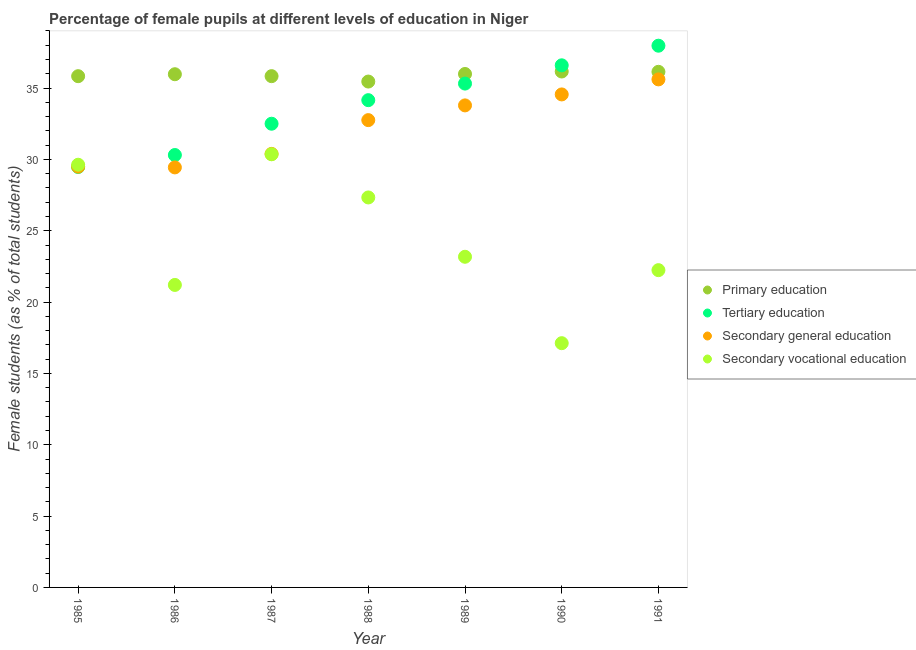What is the percentage of female students in primary education in 1989?
Your answer should be compact. 35.99. Across all years, what is the maximum percentage of female students in primary education?
Make the answer very short. 36.16. Across all years, what is the minimum percentage of female students in primary education?
Your answer should be very brief. 35.46. In which year was the percentage of female students in secondary vocational education maximum?
Provide a short and direct response. 1987. In which year was the percentage of female students in secondary education minimum?
Keep it short and to the point. 1986. What is the total percentage of female students in primary education in the graph?
Offer a very short reply. 251.38. What is the difference between the percentage of female students in tertiary education in 1985 and that in 1991?
Your response must be concise. -8.5. What is the difference between the percentage of female students in primary education in 1989 and the percentage of female students in secondary vocational education in 1988?
Offer a terse response. 8.65. What is the average percentage of female students in primary education per year?
Provide a succinct answer. 35.91. In the year 1989, what is the difference between the percentage of female students in secondary education and percentage of female students in primary education?
Offer a very short reply. -2.2. What is the ratio of the percentage of female students in secondary vocational education in 1986 to that in 1990?
Your response must be concise. 1.24. Is the percentage of female students in secondary vocational education in 1986 less than that in 1987?
Your answer should be very brief. Yes. What is the difference between the highest and the second highest percentage of female students in secondary vocational education?
Give a very brief answer. 0.73. What is the difference between the highest and the lowest percentage of female students in secondary vocational education?
Offer a terse response. 13.24. Does the percentage of female students in primary education monotonically increase over the years?
Your answer should be very brief. No. Is the percentage of female students in tertiary education strictly greater than the percentage of female students in secondary vocational education over the years?
Offer a terse response. No. How many dotlines are there?
Your answer should be compact. 4. How many years are there in the graph?
Offer a very short reply. 7. Does the graph contain any zero values?
Ensure brevity in your answer.  No. How are the legend labels stacked?
Give a very brief answer. Vertical. What is the title of the graph?
Your answer should be very brief. Percentage of female pupils at different levels of education in Niger. What is the label or title of the Y-axis?
Keep it short and to the point. Female students (as % of total students). What is the Female students (as % of total students) of Primary education in 1985?
Provide a succinct answer. 35.83. What is the Female students (as % of total students) in Tertiary education in 1985?
Offer a very short reply. 29.47. What is the Female students (as % of total students) of Secondary general education in 1985?
Ensure brevity in your answer.  29.49. What is the Female students (as % of total students) of Secondary vocational education in 1985?
Provide a succinct answer. 29.63. What is the Female students (as % of total students) in Primary education in 1986?
Offer a terse response. 35.97. What is the Female students (as % of total students) in Tertiary education in 1986?
Your answer should be very brief. 30.31. What is the Female students (as % of total students) of Secondary general education in 1986?
Offer a very short reply. 29.44. What is the Female students (as % of total students) in Secondary vocational education in 1986?
Give a very brief answer. 21.2. What is the Female students (as % of total students) of Primary education in 1987?
Your answer should be very brief. 35.83. What is the Female students (as % of total students) in Tertiary education in 1987?
Your answer should be compact. 32.5. What is the Female students (as % of total students) in Secondary general education in 1987?
Provide a short and direct response. 30.39. What is the Female students (as % of total students) of Secondary vocational education in 1987?
Offer a terse response. 30.36. What is the Female students (as % of total students) of Primary education in 1988?
Keep it short and to the point. 35.46. What is the Female students (as % of total students) of Tertiary education in 1988?
Make the answer very short. 34.15. What is the Female students (as % of total students) of Secondary general education in 1988?
Provide a short and direct response. 32.75. What is the Female students (as % of total students) in Secondary vocational education in 1988?
Make the answer very short. 27.33. What is the Female students (as % of total students) of Primary education in 1989?
Your answer should be compact. 35.99. What is the Female students (as % of total students) in Tertiary education in 1989?
Provide a short and direct response. 35.31. What is the Female students (as % of total students) of Secondary general education in 1989?
Offer a very short reply. 33.79. What is the Female students (as % of total students) of Secondary vocational education in 1989?
Offer a terse response. 23.18. What is the Female students (as % of total students) in Primary education in 1990?
Keep it short and to the point. 36.16. What is the Female students (as % of total students) in Tertiary education in 1990?
Your answer should be very brief. 36.59. What is the Female students (as % of total students) in Secondary general education in 1990?
Give a very brief answer. 34.55. What is the Female students (as % of total students) of Secondary vocational education in 1990?
Keep it short and to the point. 17.12. What is the Female students (as % of total students) in Primary education in 1991?
Ensure brevity in your answer.  36.14. What is the Female students (as % of total students) of Tertiary education in 1991?
Give a very brief answer. 37.97. What is the Female students (as % of total students) in Secondary general education in 1991?
Provide a short and direct response. 35.61. What is the Female students (as % of total students) of Secondary vocational education in 1991?
Offer a terse response. 22.24. Across all years, what is the maximum Female students (as % of total students) in Primary education?
Offer a very short reply. 36.16. Across all years, what is the maximum Female students (as % of total students) in Tertiary education?
Your response must be concise. 37.97. Across all years, what is the maximum Female students (as % of total students) of Secondary general education?
Offer a terse response. 35.61. Across all years, what is the maximum Female students (as % of total students) in Secondary vocational education?
Keep it short and to the point. 30.36. Across all years, what is the minimum Female students (as % of total students) of Primary education?
Your answer should be compact. 35.46. Across all years, what is the minimum Female students (as % of total students) in Tertiary education?
Ensure brevity in your answer.  29.47. Across all years, what is the minimum Female students (as % of total students) of Secondary general education?
Give a very brief answer. 29.44. Across all years, what is the minimum Female students (as % of total students) of Secondary vocational education?
Your answer should be very brief. 17.12. What is the total Female students (as % of total students) in Primary education in the graph?
Offer a terse response. 251.38. What is the total Female students (as % of total students) in Tertiary education in the graph?
Provide a short and direct response. 236.3. What is the total Female students (as % of total students) of Secondary general education in the graph?
Make the answer very short. 226.02. What is the total Female students (as % of total students) in Secondary vocational education in the graph?
Provide a short and direct response. 171.05. What is the difference between the Female students (as % of total students) in Primary education in 1985 and that in 1986?
Your answer should be very brief. -0.14. What is the difference between the Female students (as % of total students) in Tertiary education in 1985 and that in 1986?
Keep it short and to the point. -0.84. What is the difference between the Female students (as % of total students) of Secondary general education in 1985 and that in 1986?
Offer a very short reply. 0.05. What is the difference between the Female students (as % of total students) in Secondary vocational education in 1985 and that in 1986?
Give a very brief answer. 8.43. What is the difference between the Female students (as % of total students) of Primary education in 1985 and that in 1987?
Your answer should be compact. -0. What is the difference between the Female students (as % of total students) in Tertiary education in 1985 and that in 1987?
Make the answer very short. -3.03. What is the difference between the Female students (as % of total students) of Secondary general education in 1985 and that in 1987?
Offer a very short reply. -0.89. What is the difference between the Female students (as % of total students) of Secondary vocational education in 1985 and that in 1987?
Your answer should be very brief. -0.73. What is the difference between the Female students (as % of total students) in Primary education in 1985 and that in 1988?
Keep it short and to the point. 0.38. What is the difference between the Female students (as % of total students) of Tertiary education in 1985 and that in 1988?
Keep it short and to the point. -4.68. What is the difference between the Female students (as % of total students) in Secondary general education in 1985 and that in 1988?
Make the answer very short. -3.26. What is the difference between the Female students (as % of total students) of Secondary vocational education in 1985 and that in 1988?
Give a very brief answer. 2.29. What is the difference between the Female students (as % of total students) in Primary education in 1985 and that in 1989?
Keep it short and to the point. -0.15. What is the difference between the Female students (as % of total students) in Tertiary education in 1985 and that in 1989?
Offer a terse response. -5.85. What is the difference between the Female students (as % of total students) of Secondary general education in 1985 and that in 1989?
Keep it short and to the point. -4.29. What is the difference between the Female students (as % of total students) in Secondary vocational education in 1985 and that in 1989?
Your answer should be very brief. 6.45. What is the difference between the Female students (as % of total students) of Primary education in 1985 and that in 1990?
Give a very brief answer. -0.33. What is the difference between the Female students (as % of total students) in Tertiary education in 1985 and that in 1990?
Keep it short and to the point. -7.13. What is the difference between the Female students (as % of total students) of Secondary general education in 1985 and that in 1990?
Your answer should be compact. -5.06. What is the difference between the Female students (as % of total students) of Secondary vocational education in 1985 and that in 1990?
Provide a succinct answer. 12.51. What is the difference between the Female students (as % of total students) in Primary education in 1985 and that in 1991?
Offer a very short reply. -0.31. What is the difference between the Female students (as % of total students) of Tertiary education in 1985 and that in 1991?
Your answer should be very brief. -8.5. What is the difference between the Female students (as % of total students) of Secondary general education in 1985 and that in 1991?
Offer a very short reply. -6.12. What is the difference between the Female students (as % of total students) in Secondary vocational education in 1985 and that in 1991?
Offer a very short reply. 7.39. What is the difference between the Female students (as % of total students) in Primary education in 1986 and that in 1987?
Provide a succinct answer. 0.14. What is the difference between the Female students (as % of total students) of Tertiary education in 1986 and that in 1987?
Provide a short and direct response. -2.19. What is the difference between the Female students (as % of total students) in Secondary general education in 1986 and that in 1987?
Your answer should be very brief. -0.95. What is the difference between the Female students (as % of total students) of Secondary vocational education in 1986 and that in 1987?
Your answer should be compact. -9.16. What is the difference between the Female students (as % of total students) in Primary education in 1986 and that in 1988?
Provide a succinct answer. 0.51. What is the difference between the Female students (as % of total students) of Tertiary education in 1986 and that in 1988?
Your answer should be compact. -3.84. What is the difference between the Female students (as % of total students) of Secondary general education in 1986 and that in 1988?
Keep it short and to the point. -3.31. What is the difference between the Female students (as % of total students) of Secondary vocational education in 1986 and that in 1988?
Offer a very short reply. -6.13. What is the difference between the Female students (as % of total students) of Primary education in 1986 and that in 1989?
Keep it short and to the point. -0.02. What is the difference between the Female students (as % of total students) of Tertiary education in 1986 and that in 1989?
Your answer should be compact. -5.01. What is the difference between the Female students (as % of total students) of Secondary general education in 1986 and that in 1989?
Provide a short and direct response. -4.35. What is the difference between the Female students (as % of total students) in Secondary vocational education in 1986 and that in 1989?
Offer a very short reply. -1.97. What is the difference between the Female students (as % of total students) in Primary education in 1986 and that in 1990?
Make the answer very short. -0.19. What is the difference between the Female students (as % of total students) of Tertiary education in 1986 and that in 1990?
Give a very brief answer. -6.29. What is the difference between the Female students (as % of total students) of Secondary general education in 1986 and that in 1990?
Make the answer very short. -5.12. What is the difference between the Female students (as % of total students) of Secondary vocational education in 1986 and that in 1990?
Provide a succinct answer. 4.08. What is the difference between the Female students (as % of total students) in Primary education in 1986 and that in 1991?
Provide a short and direct response. -0.17. What is the difference between the Female students (as % of total students) of Tertiary education in 1986 and that in 1991?
Give a very brief answer. -7.66. What is the difference between the Female students (as % of total students) in Secondary general education in 1986 and that in 1991?
Keep it short and to the point. -6.17. What is the difference between the Female students (as % of total students) in Secondary vocational education in 1986 and that in 1991?
Offer a very short reply. -1.04. What is the difference between the Female students (as % of total students) in Primary education in 1987 and that in 1988?
Make the answer very short. 0.38. What is the difference between the Female students (as % of total students) in Tertiary education in 1987 and that in 1988?
Offer a terse response. -1.65. What is the difference between the Female students (as % of total students) of Secondary general education in 1987 and that in 1988?
Your response must be concise. -2.37. What is the difference between the Female students (as % of total students) of Secondary vocational education in 1987 and that in 1988?
Your answer should be compact. 3.03. What is the difference between the Female students (as % of total students) in Primary education in 1987 and that in 1989?
Your answer should be compact. -0.15. What is the difference between the Female students (as % of total students) of Tertiary education in 1987 and that in 1989?
Your response must be concise. -2.81. What is the difference between the Female students (as % of total students) in Secondary general education in 1987 and that in 1989?
Ensure brevity in your answer.  -3.4. What is the difference between the Female students (as % of total students) in Secondary vocational education in 1987 and that in 1989?
Ensure brevity in your answer.  7.18. What is the difference between the Female students (as % of total students) of Primary education in 1987 and that in 1990?
Your answer should be compact. -0.33. What is the difference between the Female students (as % of total students) of Tertiary education in 1987 and that in 1990?
Your answer should be compact. -4.09. What is the difference between the Female students (as % of total students) in Secondary general education in 1987 and that in 1990?
Give a very brief answer. -4.17. What is the difference between the Female students (as % of total students) in Secondary vocational education in 1987 and that in 1990?
Provide a succinct answer. 13.24. What is the difference between the Female students (as % of total students) of Primary education in 1987 and that in 1991?
Provide a short and direct response. -0.3. What is the difference between the Female students (as % of total students) in Tertiary education in 1987 and that in 1991?
Give a very brief answer. -5.47. What is the difference between the Female students (as % of total students) of Secondary general education in 1987 and that in 1991?
Provide a short and direct response. -5.22. What is the difference between the Female students (as % of total students) in Secondary vocational education in 1987 and that in 1991?
Make the answer very short. 8.12. What is the difference between the Female students (as % of total students) in Primary education in 1988 and that in 1989?
Provide a succinct answer. -0.53. What is the difference between the Female students (as % of total students) of Tertiary education in 1988 and that in 1989?
Your answer should be compact. -1.16. What is the difference between the Female students (as % of total students) of Secondary general education in 1988 and that in 1989?
Give a very brief answer. -1.03. What is the difference between the Female students (as % of total students) in Secondary vocational education in 1988 and that in 1989?
Provide a succinct answer. 4.16. What is the difference between the Female students (as % of total students) in Primary education in 1988 and that in 1990?
Your answer should be compact. -0.7. What is the difference between the Female students (as % of total students) of Tertiary education in 1988 and that in 1990?
Give a very brief answer. -2.44. What is the difference between the Female students (as % of total students) in Secondary general education in 1988 and that in 1990?
Provide a succinct answer. -1.8. What is the difference between the Female students (as % of total students) in Secondary vocational education in 1988 and that in 1990?
Offer a very short reply. 10.21. What is the difference between the Female students (as % of total students) of Primary education in 1988 and that in 1991?
Provide a short and direct response. -0.68. What is the difference between the Female students (as % of total students) in Tertiary education in 1988 and that in 1991?
Give a very brief answer. -3.82. What is the difference between the Female students (as % of total students) of Secondary general education in 1988 and that in 1991?
Ensure brevity in your answer.  -2.85. What is the difference between the Female students (as % of total students) of Secondary vocational education in 1988 and that in 1991?
Provide a short and direct response. 5.09. What is the difference between the Female students (as % of total students) of Primary education in 1989 and that in 1990?
Your response must be concise. -0.17. What is the difference between the Female students (as % of total students) in Tertiary education in 1989 and that in 1990?
Keep it short and to the point. -1.28. What is the difference between the Female students (as % of total students) of Secondary general education in 1989 and that in 1990?
Offer a very short reply. -0.77. What is the difference between the Female students (as % of total students) of Secondary vocational education in 1989 and that in 1990?
Offer a terse response. 6.06. What is the difference between the Female students (as % of total students) in Primary education in 1989 and that in 1991?
Give a very brief answer. -0.15. What is the difference between the Female students (as % of total students) in Tertiary education in 1989 and that in 1991?
Keep it short and to the point. -2.65. What is the difference between the Female students (as % of total students) of Secondary general education in 1989 and that in 1991?
Give a very brief answer. -1.82. What is the difference between the Female students (as % of total students) of Secondary vocational education in 1989 and that in 1991?
Your answer should be very brief. 0.94. What is the difference between the Female students (as % of total students) in Primary education in 1990 and that in 1991?
Your answer should be compact. 0.02. What is the difference between the Female students (as % of total students) of Tertiary education in 1990 and that in 1991?
Provide a short and direct response. -1.38. What is the difference between the Female students (as % of total students) in Secondary general education in 1990 and that in 1991?
Give a very brief answer. -1.05. What is the difference between the Female students (as % of total students) in Secondary vocational education in 1990 and that in 1991?
Your response must be concise. -5.12. What is the difference between the Female students (as % of total students) of Primary education in 1985 and the Female students (as % of total students) of Tertiary education in 1986?
Ensure brevity in your answer.  5.53. What is the difference between the Female students (as % of total students) in Primary education in 1985 and the Female students (as % of total students) in Secondary general education in 1986?
Offer a very short reply. 6.39. What is the difference between the Female students (as % of total students) of Primary education in 1985 and the Female students (as % of total students) of Secondary vocational education in 1986?
Keep it short and to the point. 14.63. What is the difference between the Female students (as % of total students) in Tertiary education in 1985 and the Female students (as % of total students) in Secondary general education in 1986?
Offer a very short reply. 0.03. What is the difference between the Female students (as % of total students) of Tertiary education in 1985 and the Female students (as % of total students) of Secondary vocational education in 1986?
Make the answer very short. 8.27. What is the difference between the Female students (as % of total students) of Secondary general education in 1985 and the Female students (as % of total students) of Secondary vocational education in 1986?
Your answer should be very brief. 8.29. What is the difference between the Female students (as % of total students) of Primary education in 1985 and the Female students (as % of total students) of Tertiary education in 1987?
Keep it short and to the point. 3.33. What is the difference between the Female students (as % of total students) of Primary education in 1985 and the Female students (as % of total students) of Secondary general education in 1987?
Ensure brevity in your answer.  5.45. What is the difference between the Female students (as % of total students) in Primary education in 1985 and the Female students (as % of total students) in Secondary vocational education in 1987?
Provide a succinct answer. 5.47. What is the difference between the Female students (as % of total students) in Tertiary education in 1985 and the Female students (as % of total students) in Secondary general education in 1987?
Offer a very short reply. -0.92. What is the difference between the Female students (as % of total students) of Tertiary education in 1985 and the Female students (as % of total students) of Secondary vocational education in 1987?
Your response must be concise. -0.89. What is the difference between the Female students (as % of total students) of Secondary general education in 1985 and the Female students (as % of total students) of Secondary vocational education in 1987?
Provide a succinct answer. -0.87. What is the difference between the Female students (as % of total students) in Primary education in 1985 and the Female students (as % of total students) in Tertiary education in 1988?
Ensure brevity in your answer.  1.68. What is the difference between the Female students (as % of total students) of Primary education in 1985 and the Female students (as % of total students) of Secondary general education in 1988?
Provide a succinct answer. 3.08. What is the difference between the Female students (as % of total students) of Primary education in 1985 and the Female students (as % of total students) of Secondary vocational education in 1988?
Your answer should be compact. 8.5. What is the difference between the Female students (as % of total students) of Tertiary education in 1985 and the Female students (as % of total students) of Secondary general education in 1988?
Give a very brief answer. -3.28. What is the difference between the Female students (as % of total students) in Tertiary education in 1985 and the Female students (as % of total students) in Secondary vocational education in 1988?
Offer a very short reply. 2.14. What is the difference between the Female students (as % of total students) in Secondary general education in 1985 and the Female students (as % of total students) in Secondary vocational education in 1988?
Provide a short and direct response. 2.16. What is the difference between the Female students (as % of total students) of Primary education in 1985 and the Female students (as % of total students) of Tertiary education in 1989?
Offer a terse response. 0.52. What is the difference between the Female students (as % of total students) of Primary education in 1985 and the Female students (as % of total students) of Secondary general education in 1989?
Make the answer very short. 2.05. What is the difference between the Female students (as % of total students) of Primary education in 1985 and the Female students (as % of total students) of Secondary vocational education in 1989?
Offer a terse response. 12.66. What is the difference between the Female students (as % of total students) in Tertiary education in 1985 and the Female students (as % of total students) in Secondary general education in 1989?
Provide a short and direct response. -4.32. What is the difference between the Female students (as % of total students) in Tertiary education in 1985 and the Female students (as % of total students) in Secondary vocational education in 1989?
Your response must be concise. 6.29. What is the difference between the Female students (as % of total students) of Secondary general education in 1985 and the Female students (as % of total students) of Secondary vocational education in 1989?
Your answer should be compact. 6.32. What is the difference between the Female students (as % of total students) of Primary education in 1985 and the Female students (as % of total students) of Tertiary education in 1990?
Your answer should be very brief. -0.76. What is the difference between the Female students (as % of total students) in Primary education in 1985 and the Female students (as % of total students) in Secondary general education in 1990?
Provide a short and direct response. 1.28. What is the difference between the Female students (as % of total students) in Primary education in 1985 and the Female students (as % of total students) in Secondary vocational education in 1990?
Provide a succinct answer. 18.71. What is the difference between the Female students (as % of total students) of Tertiary education in 1985 and the Female students (as % of total students) of Secondary general education in 1990?
Provide a succinct answer. -5.09. What is the difference between the Female students (as % of total students) in Tertiary education in 1985 and the Female students (as % of total students) in Secondary vocational education in 1990?
Keep it short and to the point. 12.35. What is the difference between the Female students (as % of total students) of Secondary general education in 1985 and the Female students (as % of total students) of Secondary vocational education in 1990?
Provide a short and direct response. 12.37. What is the difference between the Female students (as % of total students) of Primary education in 1985 and the Female students (as % of total students) of Tertiary education in 1991?
Provide a short and direct response. -2.14. What is the difference between the Female students (as % of total students) in Primary education in 1985 and the Female students (as % of total students) in Secondary general education in 1991?
Ensure brevity in your answer.  0.22. What is the difference between the Female students (as % of total students) of Primary education in 1985 and the Female students (as % of total students) of Secondary vocational education in 1991?
Offer a terse response. 13.59. What is the difference between the Female students (as % of total students) in Tertiary education in 1985 and the Female students (as % of total students) in Secondary general education in 1991?
Give a very brief answer. -6.14. What is the difference between the Female students (as % of total students) in Tertiary education in 1985 and the Female students (as % of total students) in Secondary vocational education in 1991?
Your answer should be very brief. 7.23. What is the difference between the Female students (as % of total students) of Secondary general education in 1985 and the Female students (as % of total students) of Secondary vocational education in 1991?
Your answer should be very brief. 7.25. What is the difference between the Female students (as % of total students) of Primary education in 1986 and the Female students (as % of total students) of Tertiary education in 1987?
Offer a terse response. 3.47. What is the difference between the Female students (as % of total students) in Primary education in 1986 and the Female students (as % of total students) in Secondary general education in 1987?
Ensure brevity in your answer.  5.58. What is the difference between the Female students (as % of total students) of Primary education in 1986 and the Female students (as % of total students) of Secondary vocational education in 1987?
Your answer should be compact. 5.61. What is the difference between the Female students (as % of total students) in Tertiary education in 1986 and the Female students (as % of total students) in Secondary general education in 1987?
Provide a short and direct response. -0.08. What is the difference between the Female students (as % of total students) in Tertiary education in 1986 and the Female students (as % of total students) in Secondary vocational education in 1987?
Give a very brief answer. -0.05. What is the difference between the Female students (as % of total students) of Secondary general education in 1986 and the Female students (as % of total students) of Secondary vocational education in 1987?
Your answer should be compact. -0.92. What is the difference between the Female students (as % of total students) of Primary education in 1986 and the Female students (as % of total students) of Tertiary education in 1988?
Provide a succinct answer. 1.82. What is the difference between the Female students (as % of total students) in Primary education in 1986 and the Female students (as % of total students) in Secondary general education in 1988?
Your answer should be very brief. 3.22. What is the difference between the Female students (as % of total students) in Primary education in 1986 and the Female students (as % of total students) in Secondary vocational education in 1988?
Offer a very short reply. 8.64. What is the difference between the Female students (as % of total students) in Tertiary education in 1986 and the Female students (as % of total students) in Secondary general education in 1988?
Provide a succinct answer. -2.45. What is the difference between the Female students (as % of total students) in Tertiary education in 1986 and the Female students (as % of total students) in Secondary vocational education in 1988?
Offer a terse response. 2.97. What is the difference between the Female students (as % of total students) in Secondary general education in 1986 and the Female students (as % of total students) in Secondary vocational education in 1988?
Provide a short and direct response. 2.11. What is the difference between the Female students (as % of total students) of Primary education in 1986 and the Female students (as % of total students) of Tertiary education in 1989?
Your answer should be compact. 0.66. What is the difference between the Female students (as % of total students) of Primary education in 1986 and the Female students (as % of total students) of Secondary general education in 1989?
Your answer should be compact. 2.18. What is the difference between the Female students (as % of total students) of Primary education in 1986 and the Female students (as % of total students) of Secondary vocational education in 1989?
Give a very brief answer. 12.79. What is the difference between the Female students (as % of total students) in Tertiary education in 1986 and the Female students (as % of total students) in Secondary general education in 1989?
Give a very brief answer. -3.48. What is the difference between the Female students (as % of total students) of Tertiary education in 1986 and the Female students (as % of total students) of Secondary vocational education in 1989?
Give a very brief answer. 7.13. What is the difference between the Female students (as % of total students) of Secondary general education in 1986 and the Female students (as % of total students) of Secondary vocational education in 1989?
Make the answer very short. 6.26. What is the difference between the Female students (as % of total students) in Primary education in 1986 and the Female students (as % of total students) in Tertiary education in 1990?
Your response must be concise. -0.62. What is the difference between the Female students (as % of total students) of Primary education in 1986 and the Female students (as % of total students) of Secondary general education in 1990?
Give a very brief answer. 1.42. What is the difference between the Female students (as % of total students) in Primary education in 1986 and the Female students (as % of total students) in Secondary vocational education in 1990?
Offer a very short reply. 18.85. What is the difference between the Female students (as % of total students) of Tertiary education in 1986 and the Female students (as % of total students) of Secondary general education in 1990?
Give a very brief answer. -4.25. What is the difference between the Female students (as % of total students) of Tertiary education in 1986 and the Female students (as % of total students) of Secondary vocational education in 1990?
Offer a very short reply. 13.19. What is the difference between the Female students (as % of total students) in Secondary general education in 1986 and the Female students (as % of total students) in Secondary vocational education in 1990?
Provide a succinct answer. 12.32. What is the difference between the Female students (as % of total students) of Primary education in 1986 and the Female students (as % of total students) of Tertiary education in 1991?
Keep it short and to the point. -2. What is the difference between the Female students (as % of total students) of Primary education in 1986 and the Female students (as % of total students) of Secondary general education in 1991?
Give a very brief answer. 0.36. What is the difference between the Female students (as % of total students) of Primary education in 1986 and the Female students (as % of total students) of Secondary vocational education in 1991?
Give a very brief answer. 13.73. What is the difference between the Female students (as % of total students) of Tertiary education in 1986 and the Female students (as % of total students) of Secondary general education in 1991?
Offer a very short reply. -5.3. What is the difference between the Female students (as % of total students) of Tertiary education in 1986 and the Female students (as % of total students) of Secondary vocational education in 1991?
Keep it short and to the point. 8.07. What is the difference between the Female students (as % of total students) in Secondary general education in 1986 and the Female students (as % of total students) in Secondary vocational education in 1991?
Make the answer very short. 7.2. What is the difference between the Female students (as % of total students) of Primary education in 1987 and the Female students (as % of total students) of Tertiary education in 1988?
Ensure brevity in your answer.  1.68. What is the difference between the Female students (as % of total students) in Primary education in 1987 and the Female students (as % of total students) in Secondary general education in 1988?
Make the answer very short. 3.08. What is the difference between the Female students (as % of total students) of Primary education in 1987 and the Female students (as % of total students) of Secondary vocational education in 1988?
Your response must be concise. 8.5. What is the difference between the Female students (as % of total students) of Tertiary education in 1987 and the Female students (as % of total students) of Secondary general education in 1988?
Offer a terse response. -0.25. What is the difference between the Female students (as % of total students) in Tertiary education in 1987 and the Female students (as % of total students) in Secondary vocational education in 1988?
Your response must be concise. 5.17. What is the difference between the Female students (as % of total students) of Secondary general education in 1987 and the Female students (as % of total students) of Secondary vocational education in 1988?
Provide a succinct answer. 3.05. What is the difference between the Female students (as % of total students) of Primary education in 1987 and the Female students (as % of total students) of Tertiary education in 1989?
Make the answer very short. 0.52. What is the difference between the Female students (as % of total students) in Primary education in 1987 and the Female students (as % of total students) in Secondary general education in 1989?
Offer a very short reply. 2.05. What is the difference between the Female students (as % of total students) in Primary education in 1987 and the Female students (as % of total students) in Secondary vocational education in 1989?
Keep it short and to the point. 12.66. What is the difference between the Female students (as % of total students) of Tertiary education in 1987 and the Female students (as % of total students) of Secondary general education in 1989?
Ensure brevity in your answer.  -1.29. What is the difference between the Female students (as % of total students) of Tertiary education in 1987 and the Female students (as % of total students) of Secondary vocational education in 1989?
Your response must be concise. 9.32. What is the difference between the Female students (as % of total students) in Secondary general education in 1987 and the Female students (as % of total students) in Secondary vocational education in 1989?
Offer a very short reply. 7.21. What is the difference between the Female students (as % of total students) of Primary education in 1987 and the Female students (as % of total students) of Tertiary education in 1990?
Ensure brevity in your answer.  -0.76. What is the difference between the Female students (as % of total students) in Primary education in 1987 and the Female students (as % of total students) in Secondary general education in 1990?
Your answer should be very brief. 1.28. What is the difference between the Female students (as % of total students) in Primary education in 1987 and the Female students (as % of total students) in Secondary vocational education in 1990?
Your answer should be very brief. 18.72. What is the difference between the Female students (as % of total students) of Tertiary education in 1987 and the Female students (as % of total students) of Secondary general education in 1990?
Provide a succinct answer. -2.05. What is the difference between the Female students (as % of total students) of Tertiary education in 1987 and the Female students (as % of total students) of Secondary vocational education in 1990?
Your response must be concise. 15.38. What is the difference between the Female students (as % of total students) in Secondary general education in 1987 and the Female students (as % of total students) in Secondary vocational education in 1990?
Keep it short and to the point. 13.27. What is the difference between the Female students (as % of total students) of Primary education in 1987 and the Female students (as % of total students) of Tertiary education in 1991?
Provide a succinct answer. -2.13. What is the difference between the Female students (as % of total students) in Primary education in 1987 and the Female students (as % of total students) in Secondary general education in 1991?
Your answer should be compact. 0.23. What is the difference between the Female students (as % of total students) in Primary education in 1987 and the Female students (as % of total students) in Secondary vocational education in 1991?
Provide a short and direct response. 13.6. What is the difference between the Female students (as % of total students) in Tertiary education in 1987 and the Female students (as % of total students) in Secondary general education in 1991?
Your answer should be compact. -3.11. What is the difference between the Female students (as % of total students) in Tertiary education in 1987 and the Female students (as % of total students) in Secondary vocational education in 1991?
Your answer should be compact. 10.26. What is the difference between the Female students (as % of total students) of Secondary general education in 1987 and the Female students (as % of total students) of Secondary vocational education in 1991?
Your answer should be very brief. 8.15. What is the difference between the Female students (as % of total students) in Primary education in 1988 and the Female students (as % of total students) in Tertiary education in 1989?
Offer a terse response. 0.14. What is the difference between the Female students (as % of total students) of Primary education in 1988 and the Female students (as % of total students) of Secondary general education in 1989?
Ensure brevity in your answer.  1.67. What is the difference between the Female students (as % of total students) in Primary education in 1988 and the Female students (as % of total students) in Secondary vocational education in 1989?
Give a very brief answer. 12.28. What is the difference between the Female students (as % of total students) in Tertiary education in 1988 and the Female students (as % of total students) in Secondary general education in 1989?
Offer a very short reply. 0.37. What is the difference between the Female students (as % of total students) in Tertiary education in 1988 and the Female students (as % of total students) in Secondary vocational education in 1989?
Give a very brief answer. 10.98. What is the difference between the Female students (as % of total students) of Secondary general education in 1988 and the Female students (as % of total students) of Secondary vocational education in 1989?
Give a very brief answer. 9.58. What is the difference between the Female students (as % of total students) in Primary education in 1988 and the Female students (as % of total students) in Tertiary education in 1990?
Offer a very short reply. -1.14. What is the difference between the Female students (as % of total students) in Primary education in 1988 and the Female students (as % of total students) in Secondary general education in 1990?
Make the answer very short. 0.9. What is the difference between the Female students (as % of total students) of Primary education in 1988 and the Female students (as % of total students) of Secondary vocational education in 1990?
Make the answer very short. 18.34. What is the difference between the Female students (as % of total students) of Tertiary education in 1988 and the Female students (as % of total students) of Secondary general education in 1990?
Your response must be concise. -0.4. What is the difference between the Female students (as % of total students) of Tertiary education in 1988 and the Female students (as % of total students) of Secondary vocational education in 1990?
Keep it short and to the point. 17.03. What is the difference between the Female students (as % of total students) of Secondary general education in 1988 and the Female students (as % of total students) of Secondary vocational education in 1990?
Give a very brief answer. 15.63. What is the difference between the Female students (as % of total students) in Primary education in 1988 and the Female students (as % of total students) in Tertiary education in 1991?
Your answer should be compact. -2.51. What is the difference between the Female students (as % of total students) in Primary education in 1988 and the Female students (as % of total students) in Secondary general education in 1991?
Provide a short and direct response. -0.15. What is the difference between the Female students (as % of total students) of Primary education in 1988 and the Female students (as % of total students) of Secondary vocational education in 1991?
Your answer should be very brief. 13.22. What is the difference between the Female students (as % of total students) of Tertiary education in 1988 and the Female students (as % of total students) of Secondary general education in 1991?
Offer a very short reply. -1.46. What is the difference between the Female students (as % of total students) of Tertiary education in 1988 and the Female students (as % of total students) of Secondary vocational education in 1991?
Make the answer very short. 11.91. What is the difference between the Female students (as % of total students) of Secondary general education in 1988 and the Female students (as % of total students) of Secondary vocational education in 1991?
Make the answer very short. 10.51. What is the difference between the Female students (as % of total students) in Primary education in 1989 and the Female students (as % of total students) in Tertiary education in 1990?
Give a very brief answer. -0.61. What is the difference between the Female students (as % of total students) in Primary education in 1989 and the Female students (as % of total students) in Secondary general education in 1990?
Your answer should be very brief. 1.43. What is the difference between the Female students (as % of total students) in Primary education in 1989 and the Female students (as % of total students) in Secondary vocational education in 1990?
Make the answer very short. 18.87. What is the difference between the Female students (as % of total students) of Tertiary education in 1989 and the Female students (as % of total students) of Secondary general education in 1990?
Provide a succinct answer. 0.76. What is the difference between the Female students (as % of total students) of Tertiary education in 1989 and the Female students (as % of total students) of Secondary vocational education in 1990?
Make the answer very short. 18.2. What is the difference between the Female students (as % of total students) in Secondary general education in 1989 and the Female students (as % of total students) in Secondary vocational education in 1990?
Provide a short and direct response. 16.67. What is the difference between the Female students (as % of total students) in Primary education in 1989 and the Female students (as % of total students) in Tertiary education in 1991?
Your response must be concise. -1.98. What is the difference between the Female students (as % of total students) in Primary education in 1989 and the Female students (as % of total students) in Secondary general education in 1991?
Your response must be concise. 0.38. What is the difference between the Female students (as % of total students) in Primary education in 1989 and the Female students (as % of total students) in Secondary vocational education in 1991?
Make the answer very short. 13.75. What is the difference between the Female students (as % of total students) of Tertiary education in 1989 and the Female students (as % of total students) of Secondary general education in 1991?
Your answer should be compact. -0.29. What is the difference between the Female students (as % of total students) in Tertiary education in 1989 and the Female students (as % of total students) in Secondary vocational education in 1991?
Offer a terse response. 13.08. What is the difference between the Female students (as % of total students) in Secondary general education in 1989 and the Female students (as % of total students) in Secondary vocational education in 1991?
Offer a very short reply. 11.55. What is the difference between the Female students (as % of total students) in Primary education in 1990 and the Female students (as % of total students) in Tertiary education in 1991?
Keep it short and to the point. -1.81. What is the difference between the Female students (as % of total students) of Primary education in 1990 and the Female students (as % of total students) of Secondary general education in 1991?
Ensure brevity in your answer.  0.55. What is the difference between the Female students (as % of total students) in Primary education in 1990 and the Female students (as % of total students) in Secondary vocational education in 1991?
Your response must be concise. 13.92. What is the difference between the Female students (as % of total students) of Tertiary education in 1990 and the Female students (as % of total students) of Secondary general education in 1991?
Provide a short and direct response. 0.99. What is the difference between the Female students (as % of total students) in Tertiary education in 1990 and the Female students (as % of total students) in Secondary vocational education in 1991?
Offer a terse response. 14.36. What is the difference between the Female students (as % of total students) in Secondary general education in 1990 and the Female students (as % of total students) in Secondary vocational education in 1991?
Give a very brief answer. 12.32. What is the average Female students (as % of total students) of Primary education per year?
Offer a terse response. 35.91. What is the average Female students (as % of total students) in Tertiary education per year?
Provide a short and direct response. 33.76. What is the average Female students (as % of total students) in Secondary general education per year?
Give a very brief answer. 32.29. What is the average Female students (as % of total students) of Secondary vocational education per year?
Your answer should be compact. 24.44. In the year 1985, what is the difference between the Female students (as % of total students) of Primary education and Female students (as % of total students) of Tertiary education?
Provide a short and direct response. 6.36. In the year 1985, what is the difference between the Female students (as % of total students) of Primary education and Female students (as % of total students) of Secondary general education?
Give a very brief answer. 6.34. In the year 1985, what is the difference between the Female students (as % of total students) in Primary education and Female students (as % of total students) in Secondary vocational education?
Give a very brief answer. 6.21. In the year 1985, what is the difference between the Female students (as % of total students) in Tertiary education and Female students (as % of total students) in Secondary general education?
Offer a terse response. -0.02. In the year 1985, what is the difference between the Female students (as % of total students) of Tertiary education and Female students (as % of total students) of Secondary vocational education?
Ensure brevity in your answer.  -0.16. In the year 1985, what is the difference between the Female students (as % of total students) of Secondary general education and Female students (as % of total students) of Secondary vocational education?
Your answer should be compact. -0.13. In the year 1986, what is the difference between the Female students (as % of total students) in Primary education and Female students (as % of total students) in Tertiary education?
Ensure brevity in your answer.  5.66. In the year 1986, what is the difference between the Female students (as % of total students) of Primary education and Female students (as % of total students) of Secondary general education?
Offer a very short reply. 6.53. In the year 1986, what is the difference between the Female students (as % of total students) of Primary education and Female students (as % of total students) of Secondary vocational education?
Give a very brief answer. 14.77. In the year 1986, what is the difference between the Female students (as % of total students) of Tertiary education and Female students (as % of total students) of Secondary general education?
Your answer should be very brief. 0.87. In the year 1986, what is the difference between the Female students (as % of total students) in Tertiary education and Female students (as % of total students) in Secondary vocational education?
Offer a very short reply. 9.11. In the year 1986, what is the difference between the Female students (as % of total students) of Secondary general education and Female students (as % of total students) of Secondary vocational education?
Your answer should be compact. 8.24. In the year 1987, what is the difference between the Female students (as % of total students) in Primary education and Female students (as % of total students) in Tertiary education?
Provide a short and direct response. 3.33. In the year 1987, what is the difference between the Female students (as % of total students) of Primary education and Female students (as % of total students) of Secondary general education?
Your response must be concise. 5.45. In the year 1987, what is the difference between the Female students (as % of total students) in Primary education and Female students (as % of total students) in Secondary vocational education?
Provide a succinct answer. 5.47. In the year 1987, what is the difference between the Female students (as % of total students) of Tertiary education and Female students (as % of total students) of Secondary general education?
Offer a very short reply. 2.11. In the year 1987, what is the difference between the Female students (as % of total students) in Tertiary education and Female students (as % of total students) in Secondary vocational education?
Your answer should be compact. 2.14. In the year 1987, what is the difference between the Female students (as % of total students) of Secondary general education and Female students (as % of total students) of Secondary vocational education?
Provide a short and direct response. 0.03. In the year 1988, what is the difference between the Female students (as % of total students) in Primary education and Female students (as % of total students) in Tertiary education?
Offer a terse response. 1.3. In the year 1988, what is the difference between the Female students (as % of total students) of Primary education and Female students (as % of total students) of Secondary general education?
Your response must be concise. 2.7. In the year 1988, what is the difference between the Female students (as % of total students) of Primary education and Female students (as % of total students) of Secondary vocational education?
Offer a very short reply. 8.12. In the year 1988, what is the difference between the Female students (as % of total students) in Tertiary education and Female students (as % of total students) in Secondary general education?
Give a very brief answer. 1.4. In the year 1988, what is the difference between the Female students (as % of total students) in Tertiary education and Female students (as % of total students) in Secondary vocational education?
Your answer should be very brief. 6.82. In the year 1988, what is the difference between the Female students (as % of total students) of Secondary general education and Female students (as % of total students) of Secondary vocational education?
Offer a very short reply. 5.42. In the year 1989, what is the difference between the Female students (as % of total students) in Primary education and Female students (as % of total students) in Tertiary education?
Your response must be concise. 0.67. In the year 1989, what is the difference between the Female students (as % of total students) of Primary education and Female students (as % of total students) of Secondary general education?
Your response must be concise. 2.2. In the year 1989, what is the difference between the Female students (as % of total students) of Primary education and Female students (as % of total students) of Secondary vocational education?
Make the answer very short. 12.81. In the year 1989, what is the difference between the Female students (as % of total students) of Tertiary education and Female students (as % of total students) of Secondary general education?
Give a very brief answer. 1.53. In the year 1989, what is the difference between the Female students (as % of total students) of Tertiary education and Female students (as % of total students) of Secondary vocational education?
Provide a short and direct response. 12.14. In the year 1989, what is the difference between the Female students (as % of total students) in Secondary general education and Female students (as % of total students) in Secondary vocational education?
Make the answer very short. 10.61. In the year 1990, what is the difference between the Female students (as % of total students) in Primary education and Female students (as % of total students) in Tertiary education?
Offer a very short reply. -0.43. In the year 1990, what is the difference between the Female students (as % of total students) of Primary education and Female students (as % of total students) of Secondary general education?
Offer a very short reply. 1.61. In the year 1990, what is the difference between the Female students (as % of total students) in Primary education and Female students (as % of total students) in Secondary vocational education?
Your answer should be very brief. 19.04. In the year 1990, what is the difference between the Female students (as % of total students) of Tertiary education and Female students (as % of total students) of Secondary general education?
Keep it short and to the point. 2.04. In the year 1990, what is the difference between the Female students (as % of total students) of Tertiary education and Female students (as % of total students) of Secondary vocational education?
Give a very brief answer. 19.48. In the year 1990, what is the difference between the Female students (as % of total students) in Secondary general education and Female students (as % of total students) in Secondary vocational education?
Give a very brief answer. 17.44. In the year 1991, what is the difference between the Female students (as % of total students) in Primary education and Female students (as % of total students) in Tertiary education?
Your answer should be compact. -1.83. In the year 1991, what is the difference between the Female students (as % of total students) of Primary education and Female students (as % of total students) of Secondary general education?
Provide a short and direct response. 0.53. In the year 1991, what is the difference between the Female students (as % of total students) of Primary education and Female students (as % of total students) of Secondary vocational education?
Provide a succinct answer. 13.9. In the year 1991, what is the difference between the Female students (as % of total students) of Tertiary education and Female students (as % of total students) of Secondary general education?
Provide a short and direct response. 2.36. In the year 1991, what is the difference between the Female students (as % of total students) of Tertiary education and Female students (as % of total students) of Secondary vocational education?
Offer a terse response. 15.73. In the year 1991, what is the difference between the Female students (as % of total students) of Secondary general education and Female students (as % of total students) of Secondary vocational education?
Offer a very short reply. 13.37. What is the ratio of the Female students (as % of total students) of Tertiary education in 1985 to that in 1986?
Make the answer very short. 0.97. What is the ratio of the Female students (as % of total students) in Secondary general education in 1985 to that in 1986?
Ensure brevity in your answer.  1. What is the ratio of the Female students (as % of total students) in Secondary vocational education in 1985 to that in 1986?
Offer a terse response. 1.4. What is the ratio of the Female students (as % of total students) of Primary education in 1985 to that in 1987?
Make the answer very short. 1. What is the ratio of the Female students (as % of total students) of Tertiary education in 1985 to that in 1987?
Your answer should be very brief. 0.91. What is the ratio of the Female students (as % of total students) in Secondary general education in 1985 to that in 1987?
Your answer should be compact. 0.97. What is the ratio of the Female students (as % of total students) of Secondary vocational education in 1985 to that in 1987?
Your answer should be compact. 0.98. What is the ratio of the Female students (as % of total students) in Primary education in 1985 to that in 1988?
Make the answer very short. 1.01. What is the ratio of the Female students (as % of total students) of Tertiary education in 1985 to that in 1988?
Your response must be concise. 0.86. What is the ratio of the Female students (as % of total students) of Secondary general education in 1985 to that in 1988?
Your response must be concise. 0.9. What is the ratio of the Female students (as % of total students) of Secondary vocational education in 1985 to that in 1988?
Provide a succinct answer. 1.08. What is the ratio of the Female students (as % of total students) in Primary education in 1985 to that in 1989?
Provide a short and direct response. 1. What is the ratio of the Female students (as % of total students) of Tertiary education in 1985 to that in 1989?
Provide a short and direct response. 0.83. What is the ratio of the Female students (as % of total students) of Secondary general education in 1985 to that in 1989?
Give a very brief answer. 0.87. What is the ratio of the Female students (as % of total students) in Secondary vocational education in 1985 to that in 1989?
Ensure brevity in your answer.  1.28. What is the ratio of the Female students (as % of total students) of Primary education in 1985 to that in 1990?
Your answer should be compact. 0.99. What is the ratio of the Female students (as % of total students) in Tertiary education in 1985 to that in 1990?
Ensure brevity in your answer.  0.81. What is the ratio of the Female students (as % of total students) of Secondary general education in 1985 to that in 1990?
Keep it short and to the point. 0.85. What is the ratio of the Female students (as % of total students) of Secondary vocational education in 1985 to that in 1990?
Give a very brief answer. 1.73. What is the ratio of the Female students (as % of total students) in Tertiary education in 1985 to that in 1991?
Offer a very short reply. 0.78. What is the ratio of the Female students (as % of total students) in Secondary general education in 1985 to that in 1991?
Offer a very short reply. 0.83. What is the ratio of the Female students (as % of total students) of Secondary vocational education in 1985 to that in 1991?
Make the answer very short. 1.33. What is the ratio of the Female students (as % of total students) in Tertiary education in 1986 to that in 1987?
Provide a short and direct response. 0.93. What is the ratio of the Female students (as % of total students) of Secondary general education in 1986 to that in 1987?
Your answer should be compact. 0.97. What is the ratio of the Female students (as % of total students) in Secondary vocational education in 1986 to that in 1987?
Ensure brevity in your answer.  0.7. What is the ratio of the Female students (as % of total students) in Primary education in 1986 to that in 1988?
Make the answer very short. 1.01. What is the ratio of the Female students (as % of total students) in Tertiary education in 1986 to that in 1988?
Keep it short and to the point. 0.89. What is the ratio of the Female students (as % of total students) of Secondary general education in 1986 to that in 1988?
Offer a very short reply. 0.9. What is the ratio of the Female students (as % of total students) in Secondary vocational education in 1986 to that in 1988?
Offer a very short reply. 0.78. What is the ratio of the Female students (as % of total students) of Tertiary education in 1986 to that in 1989?
Your answer should be very brief. 0.86. What is the ratio of the Female students (as % of total students) of Secondary general education in 1986 to that in 1989?
Provide a short and direct response. 0.87. What is the ratio of the Female students (as % of total students) of Secondary vocational education in 1986 to that in 1989?
Give a very brief answer. 0.91. What is the ratio of the Female students (as % of total students) in Primary education in 1986 to that in 1990?
Your answer should be very brief. 0.99. What is the ratio of the Female students (as % of total students) of Tertiary education in 1986 to that in 1990?
Offer a terse response. 0.83. What is the ratio of the Female students (as % of total students) in Secondary general education in 1986 to that in 1990?
Ensure brevity in your answer.  0.85. What is the ratio of the Female students (as % of total students) in Secondary vocational education in 1986 to that in 1990?
Make the answer very short. 1.24. What is the ratio of the Female students (as % of total students) of Primary education in 1986 to that in 1991?
Your answer should be compact. 1. What is the ratio of the Female students (as % of total students) in Tertiary education in 1986 to that in 1991?
Provide a short and direct response. 0.8. What is the ratio of the Female students (as % of total students) of Secondary general education in 1986 to that in 1991?
Your answer should be very brief. 0.83. What is the ratio of the Female students (as % of total students) of Secondary vocational education in 1986 to that in 1991?
Your answer should be very brief. 0.95. What is the ratio of the Female students (as % of total students) of Primary education in 1987 to that in 1988?
Offer a terse response. 1.01. What is the ratio of the Female students (as % of total students) of Tertiary education in 1987 to that in 1988?
Keep it short and to the point. 0.95. What is the ratio of the Female students (as % of total students) in Secondary general education in 1987 to that in 1988?
Provide a short and direct response. 0.93. What is the ratio of the Female students (as % of total students) in Secondary vocational education in 1987 to that in 1988?
Offer a terse response. 1.11. What is the ratio of the Female students (as % of total students) of Tertiary education in 1987 to that in 1989?
Your response must be concise. 0.92. What is the ratio of the Female students (as % of total students) in Secondary general education in 1987 to that in 1989?
Your answer should be compact. 0.9. What is the ratio of the Female students (as % of total students) in Secondary vocational education in 1987 to that in 1989?
Provide a succinct answer. 1.31. What is the ratio of the Female students (as % of total students) in Tertiary education in 1987 to that in 1990?
Your response must be concise. 0.89. What is the ratio of the Female students (as % of total students) of Secondary general education in 1987 to that in 1990?
Your answer should be compact. 0.88. What is the ratio of the Female students (as % of total students) in Secondary vocational education in 1987 to that in 1990?
Provide a short and direct response. 1.77. What is the ratio of the Female students (as % of total students) of Tertiary education in 1987 to that in 1991?
Make the answer very short. 0.86. What is the ratio of the Female students (as % of total students) of Secondary general education in 1987 to that in 1991?
Your response must be concise. 0.85. What is the ratio of the Female students (as % of total students) of Secondary vocational education in 1987 to that in 1991?
Your response must be concise. 1.37. What is the ratio of the Female students (as % of total students) of Primary education in 1988 to that in 1989?
Your response must be concise. 0.99. What is the ratio of the Female students (as % of total students) in Tertiary education in 1988 to that in 1989?
Your answer should be compact. 0.97. What is the ratio of the Female students (as % of total students) of Secondary general education in 1988 to that in 1989?
Your answer should be very brief. 0.97. What is the ratio of the Female students (as % of total students) in Secondary vocational education in 1988 to that in 1989?
Give a very brief answer. 1.18. What is the ratio of the Female students (as % of total students) in Primary education in 1988 to that in 1990?
Provide a succinct answer. 0.98. What is the ratio of the Female students (as % of total students) in Secondary general education in 1988 to that in 1990?
Keep it short and to the point. 0.95. What is the ratio of the Female students (as % of total students) in Secondary vocational education in 1988 to that in 1990?
Provide a short and direct response. 1.6. What is the ratio of the Female students (as % of total students) in Primary education in 1988 to that in 1991?
Provide a succinct answer. 0.98. What is the ratio of the Female students (as % of total students) of Tertiary education in 1988 to that in 1991?
Give a very brief answer. 0.9. What is the ratio of the Female students (as % of total students) in Secondary general education in 1988 to that in 1991?
Your answer should be very brief. 0.92. What is the ratio of the Female students (as % of total students) of Secondary vocational education in 1988 to that in 1991?
Your answer should be compact. 1.23. What is the ratio of the Female students (as % of total students) of Primary education in 1989 to that in 1990?
Provide a succinct answer. 1. What is the ratio of the Female students (as % of total students) in Tertiary education in 1989 to that in 1990?
Give a very brief answer. 0.96. What is the ratio of the Female students (as % of total students) of Secondary general education in 1989 to that in 1990?
Make the answer very short. 0.98. What is the ratio of the Female students (as % of total students) of Secondary vocational education in 1989 to that in 1990?
Your response must be concise. 1.35. What is the ratio of the Female students (as % of total students) in Tertiary education in 1989 to that in 1991?
Provide a succinct answer. 0.93. What is the ratio of the Female students (as % of total students) in Secondary general education in 1989 to that in 1991?
Provide a succinct answer. 0.95. What is the ratio of the Female students (as % of total students) in Secondary vocational education in 1989 to that in 1991?
Offer a terse response. 1.04. What is the ratio of the Female students (as % of total students) of Primary education in 1990 to that in 1991?
Make the answer very short. 1. What is the ratio of the Female students (as % of total students) in Tertiary education in 1990 to that in 1991?
Your answer should be compact. 0.96. What is the ratio of the Female students (as % of total students) in Secondary general education in 1990 to that in 1991?
Provide a succinct answer. 0.97. What is the ratio of the Female students (as % of total students) in Secondary vocational education in 1990 to that in 1991?
Offer a terse response. 0.77. What is the difference between the highest and the second highest Female students (as % of total students) in Primary education?
Your response must be concise. 0.02. What is the difference between the highest and the second highest Female students (as % of total students) in Tertiary education?
Ensure brevity in your answer.  1.38. What is the difference between the highest and the second highest Female students (as % of total students) of Secondary general education?
Make the answer very short. 1.05. What is the difference between the highest and the second highest Female students (as % of total students) in Secondary vocational education?
Ensure brevity in your answer.  0.73. What is the difference between the highest and the lowest Female students (as % of total students) of Primary education?
Provide a succinct answer. 0.7. What is the difference between the highest and the lowest Female students (as % of total students) in Tertiary education?
Keep it short and to the point. 8.5. What is the difference between the highest and the lowest Female students (as % of total students) in Secondary general education?
Your answer should be compact. 6.17. What is the difference between the highest and the lowest Female students (as % of total students) in Secondary vocational education?
Offer a terse response. 13.24. 